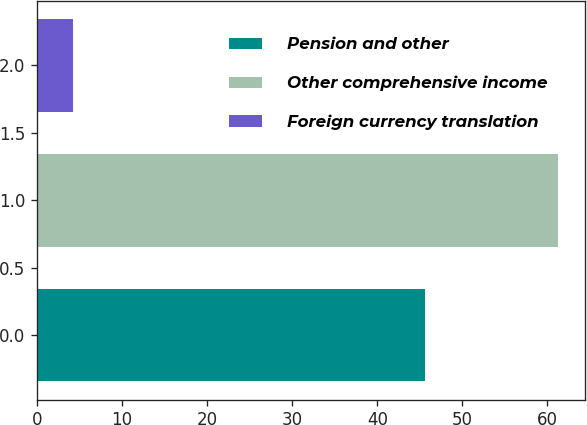<chart> <loc_0><loc_0><loc_500><loc_500><bar_chart><fcel>Pension and other<fcel>Other comprehensive income<fcel>Foreign currency translation<nl><fcel>45.6<fcel>61.3<fcel>4.2<nl></chart> 